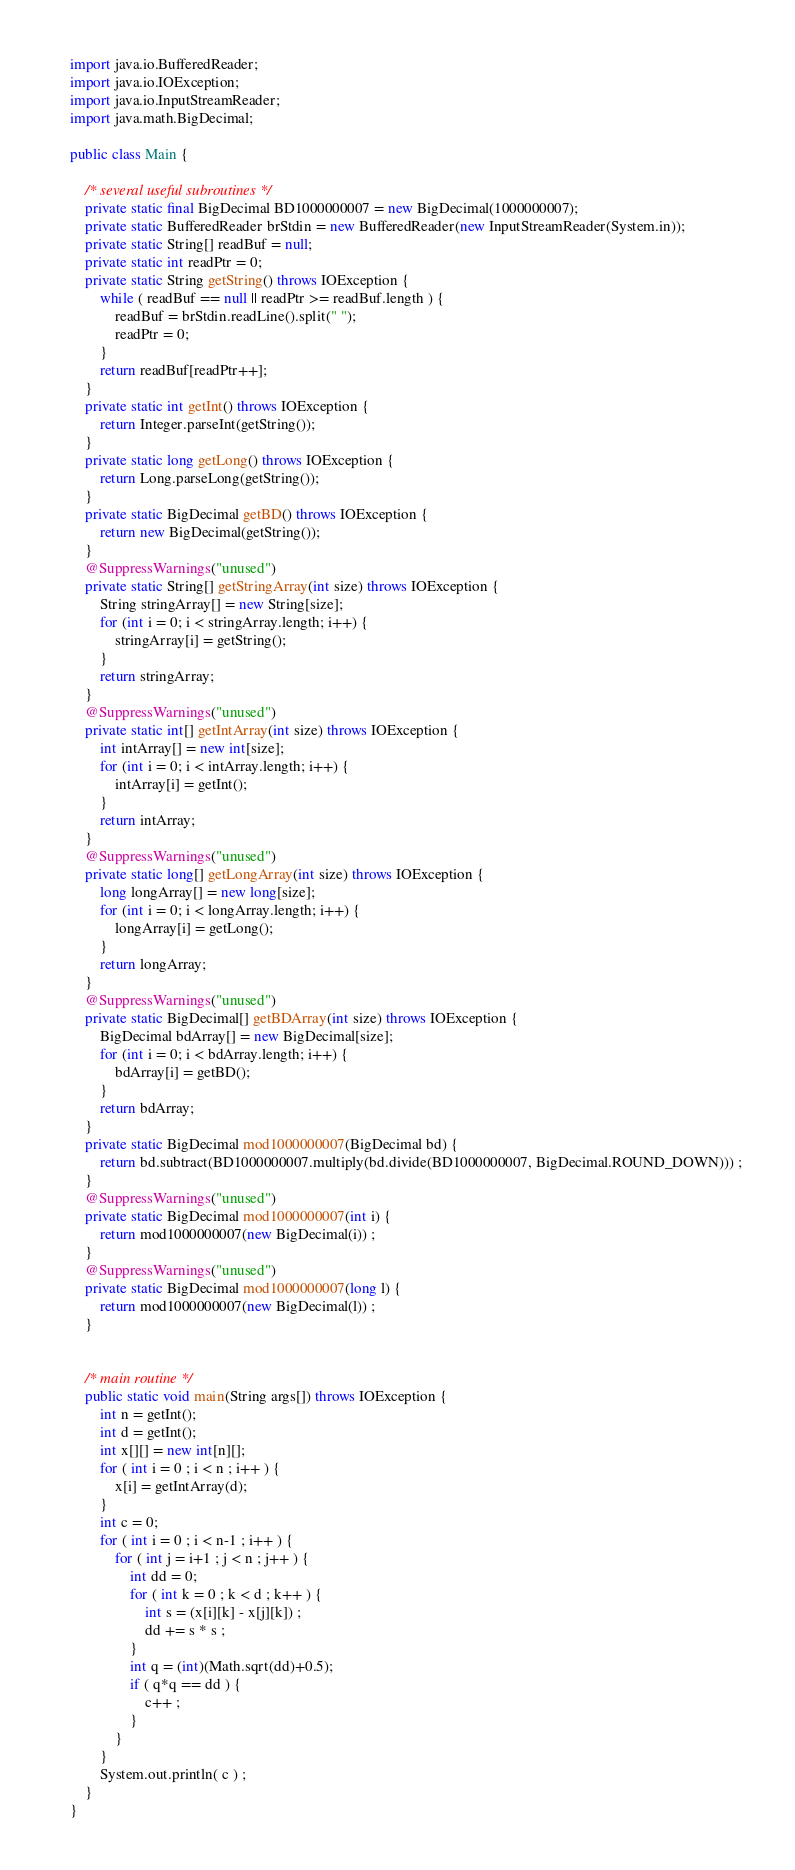Convert code to text. <code><loc_0><loc_0><loc_500><loc_500><_Java_>import java.io.BufferedReader;
import java.io.IOException;
import java.io.InputStreamReader;
import java.math.BigDecimal;

public class Main {

	/* several useful subroutines */
	private static final BigDecimal BD1000000007 = new BigDecimal(1000000007);
	private static BufferedReader brStdin = new BufferedReader(new InputStreamReader(System.in));
	private static String[] readBuf = null;
	private static int readPtr = 0;
	private static String getString() throws IOException {
		while ( readBuf == null || readPtr >= readBuf.length ) {
			readBuf = brStdin.readLine().split(" ");
			readPtr = 0;
		}
		return readBuf[readPtr++];
	}
	private static int getInt() throws IOException {
		return Integer.parseInt(getString());
	}
	private static long getLong() throws IOException {
		return Long.parseLong(getString());
	}
	private static BigDecimal getBD() throws IOException {
		return new BigDecimal(getString());
	}
	@SuppressWarnings("unused")
	private static String[] getStringArray(int size) throws IOException {
		String stringArray[] = new String[size];
		for (int i = 0; i < stringArray.length; i++) {
			stringArray[i] = getString();
		}
		return stringArray;
	}
	@SuppressWarnings("unused")
	private static int[] getIntArray(int size) throws IOException {
		int intArray[] = new int[size];
		for (int i = 0; i < intArray.length; i++) {
			intArray[i] = getInt();
		}
		return intArray;
	}
	@SuppressWarnings("unused")
	private static long[] getLongArray(int size) throws IOException {
		long longArray[] = new long[size];
		for (int i = 0; i < longArray.length; i++) {
			longArray[i] = getLong();
		}
		return longArray;
	}
	@SuppressWarnings("unused")
	private static BigDecimal[] getBDArray(int size) throws IOException {
		BigDecimal bdArray[] = new BigDecimal[size];
		for (int i = 0; i < bdArray.length; i++) {
			bdArray[i] = getBD();
		}
		return bdArray;
	}
	private static BigDecimal mod1000000007(BigDecimal bd) {
		return bd.subtract(BD1000000007.multiply(bd.divide(BD1000000007, BigDecimal.ROUND_DOWN))) ;
	}
	@SuppressWarnings("unused")
	private static BigDecimal mod1000000007(int i) {
		return mod1000000007(new BigDecimal(i)) ;
	}
	@SuppressWarnings("unused")
	private static BigDecimal mod1000000007(long l) {
		return mod1000000007(new BigDecimal(l)) ;
	}

	
	/* main routine */
	public static void main(String args[]) throws IOException {
		int n = getInt();
		int d = getInt();
		int x[][] = new int[n][];
		for ( int i = 0 ; i < n ; i++ ) {
			x[i] = getIntArray(d);
		}
		int c = 0;
		for ( int i = 0 ; i < n-1 ; i++ ) {
			for ( int j = i+1 ; j < n ; j++ ) {
				int dd = 0;
				for ( int k = 0 ; k < d ; k++ ) {
					int s = (x[i][k] - x[j][k]) ;
					dd += s * s ;
				}
				int q = (int)(Math.sqrt(dd)+0.5);
				if ( q*q == dd ) {
					c++ ;
				}
			}
		}
		System.out.println( c ) ;
	}
}
</code> 